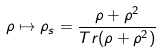Convert formula to latex. <formula><loc_0><loc_0><loc_500><loc_500>\rho \mapsto { \rho _ { s } } = \frac { \rho + \rho ^ { 2 } } { T r { ( \rho + \rho ^ { 2 } ) } }</formula> 